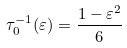<formula> <loc_0><loc_0><loc_500><loc_500>\tau _ { 0 } ^ { - 1 } ( \varepsilon ) = \frac { 1 - \varepsilon ^ { 2 } } { 6 }</formula> 